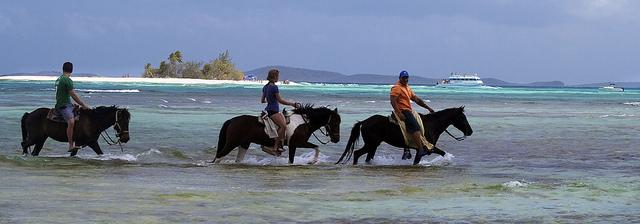What is the terrain with trees on it?

Choices:
A) savanna
B) private island
C) peninsula
D) plain private island 